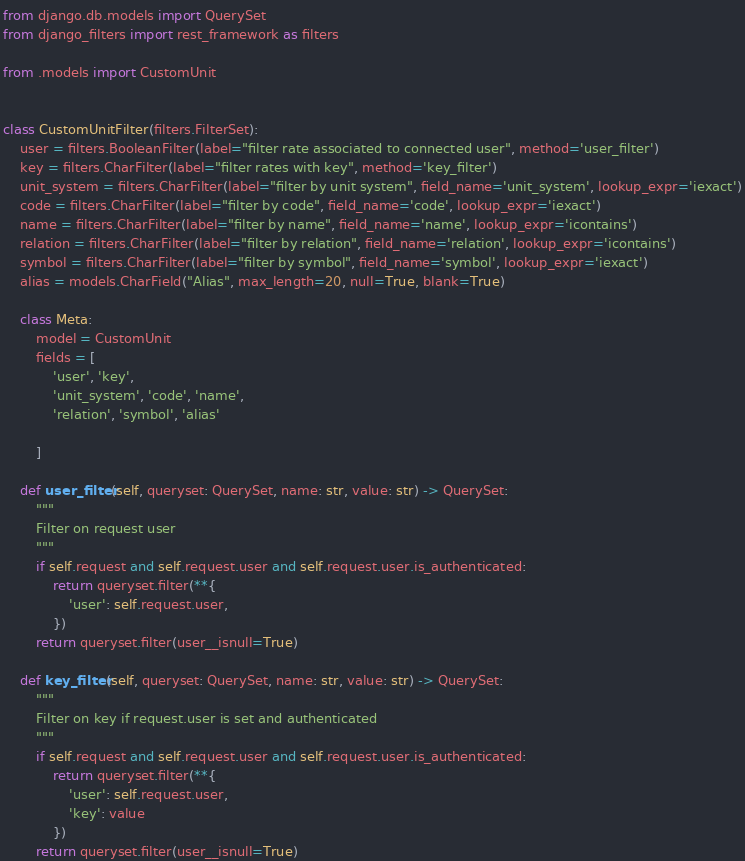Convert code to text. <code><loc_0><loc_0><loc_500><loc_500><_Python_>from django.db.models import QuerySet
from django_filters import rest_framework as filters

from .models import CustomUnit


class CustomUnitFilter(filters.FilterSet):
    user = filters.BooleanFilter(label="filter rate associated to connected user", method='user_filter')
    key = filters.CharFilter(label="filter rates with key", method='key_filter')
    unit_system = filters.CharFilter(label="filter by unit system", field_name='unit_system', lookup_expr='iexact')
    code = filters.CharFilter(label="filter by code", field_name='code', lookup_expr='iexact')
    name = filters.CharFilter(label="filter by name", field_name='name', lookup_expr='icontains')
    relation = filters.CharFilter(label="filter by relation", field_name='relation', lookup_expr='icontains')
    symbol = filters.CharFilter(label="filter by symbol", field_name='symbol', lookup_expr='iexact')
    alias = models.CharField("Alias", max_length=20, null=True, blank=True)

    class Meta:
        model = CustomUnit
        fields = [
            'user', 'key',
            'unit_system', 'code', 'name',
            'relation', 'symbol', 'alias'

        ]

    def user_filter(self, queryset: QuerySet, name: str, value: str) -> QuerySet:
        """
        Filter on request user
        """
        if self.request and self.request.user and self.request.user.is_authenticated:
            return queryset.filter(**{
                'user': self.request.user,
            })
        return queryset.filter(user__isnull=True)

    def key_filter(self, queryset: QuerySet, name: str, value: str) -> QuerySet:
        """
        Filter on key if request.user is set and authenticated
        """
        if self.request and self.request.user and self.request.user.is_authenticated:
            return queryset.filter(**{
                'user': self.request.user,
                'key': value
            })
        return queryset.filter(user__isnull=True)
</code> 